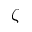<formula> <loc_0><loc_0><loc_500><loc_500>\zeta</formula> 